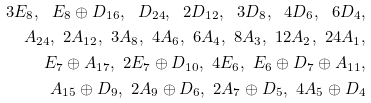Convert formula to latex. <formula><loc_0><loc_0><loc_500><loc_500>3 E _ { 8 } , \ E _ { 8 } \oplus D _ { 1 6 } , \ D _ { 2 4 } , \ 2 D _ { 1 2 } , \ 3 D _ { 8 } , \ 4 D _ { 6 } , \ 6 D _ { 4 } , \\ A _ { 2 4 } , \ 2 A _ { 1 2 } , \ 3 A _ { 8 } , \ 4 A _ { 6 } , \ 6 A _ { 4 } , \ 8 A _ { 3 } , \ 1 2 A _ { 2 } , \ 2 4 A _ { 1 } , \\ E _ { 7 } \oplus A _ { 1 7 } , \ 2 E _ { 7 } \oplus D _ { 1 0 } , \ 4 E _ { 6 } , \ E _ { 6 } \oplus D _ { 7 } \oplus A _ { 1 1 } , \\ A _ { 1 5 } \oplus D _ { 9 } , \ 2 A _ { 9 } \oplus D _ { 6 } , \ 2 A _ { 7 } \oplus D _ { 5 } , \ 4 A _ { 5 } \oplus D _ { 4 }</formula> 